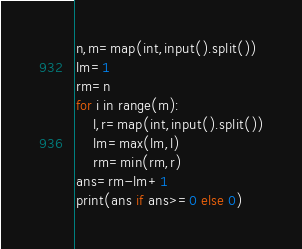Convert code to text. <code><loc_0><loc_0><loc_500><loc_500><_Python_>n,m=map(int,input().split())
lm=1
rm=n
for i in range(m):
	l,r=map(int,input().split())
	lm=max(lm,l)
	rm=min(rm,r)
ans=rm-lm+1
print(ans if ans>=0 else 0)</code> 